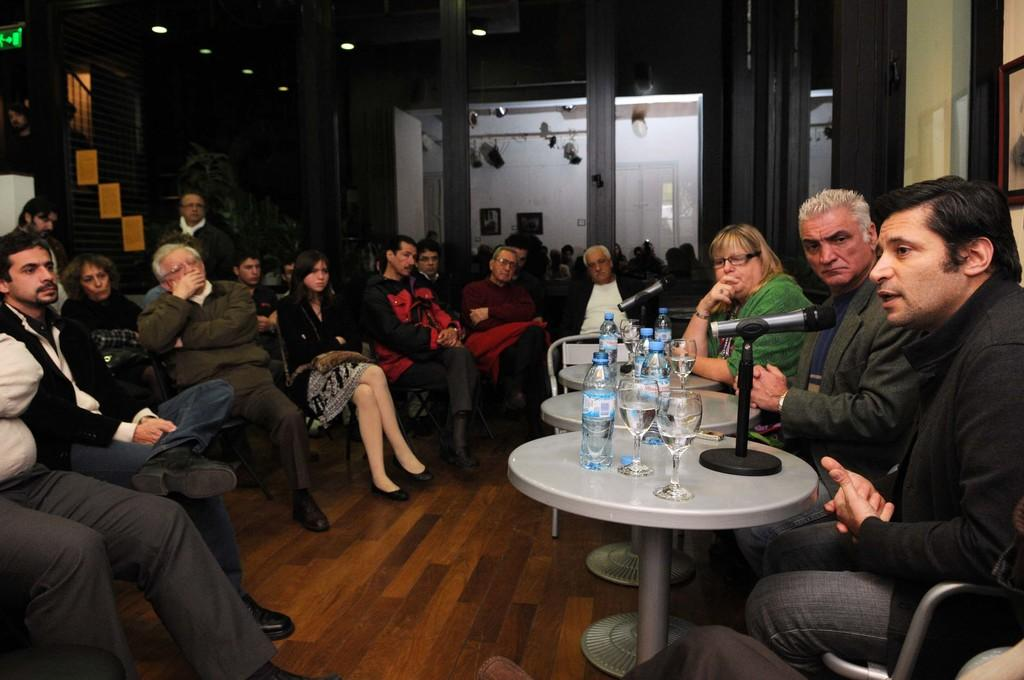What are the people in the image doing? The people in the image are sitting on chairs. What can be seen on the right side of the image? There are tables on the right side of the image. What is placed on the tables? There are bottles, glasses, and a microphone on the tables. What is visible in the background of the image? There are glass doors in the background. Can you tell me how many horses are visible in the image? There are no horses present in the image. What type of store can be seen in the background of the image? There is no store visible in the image; it only shows people sitting on chairs, tables, and glass doors in the background. 